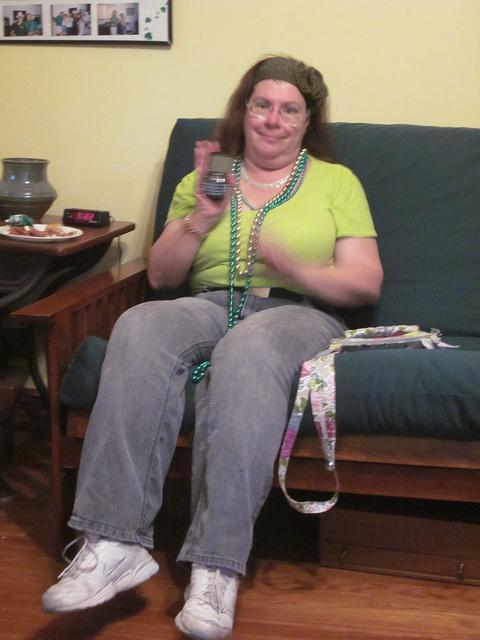What is the woman celebrating with her beads?
Answer the question by selecting the correct answer among the 4 following choices and explain your choice with a short sentence. The answer should be formatted with the following format: `Answer: choice
Rationale: rationale.`
Options: Easter, halloween, christmas, mardi gras. Answer: mardi gras.
Rationale: The lady seems to be having something in her hand. 